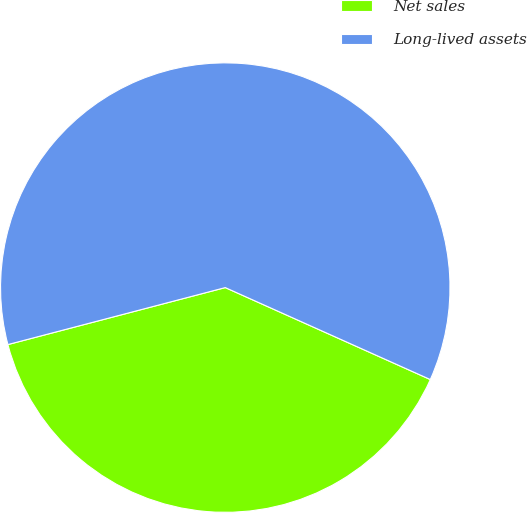Convert chart. <chart><loc_0><loc_0><loc_500><loc_500><pie_chart><fcel>Net sales<fcel>Long-lived assets<nl><fcel>39.21%<fcel>60.79%<nl></chart> 